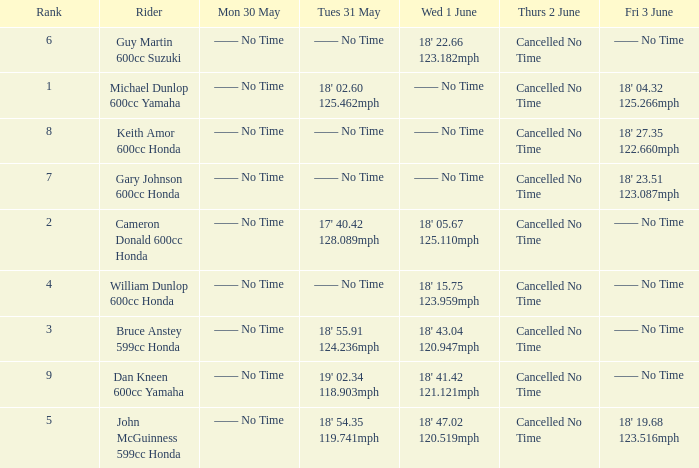What is the rank of the rider whose Tues 31 May time was 19' 02.34 118.903mph? 9.0. 